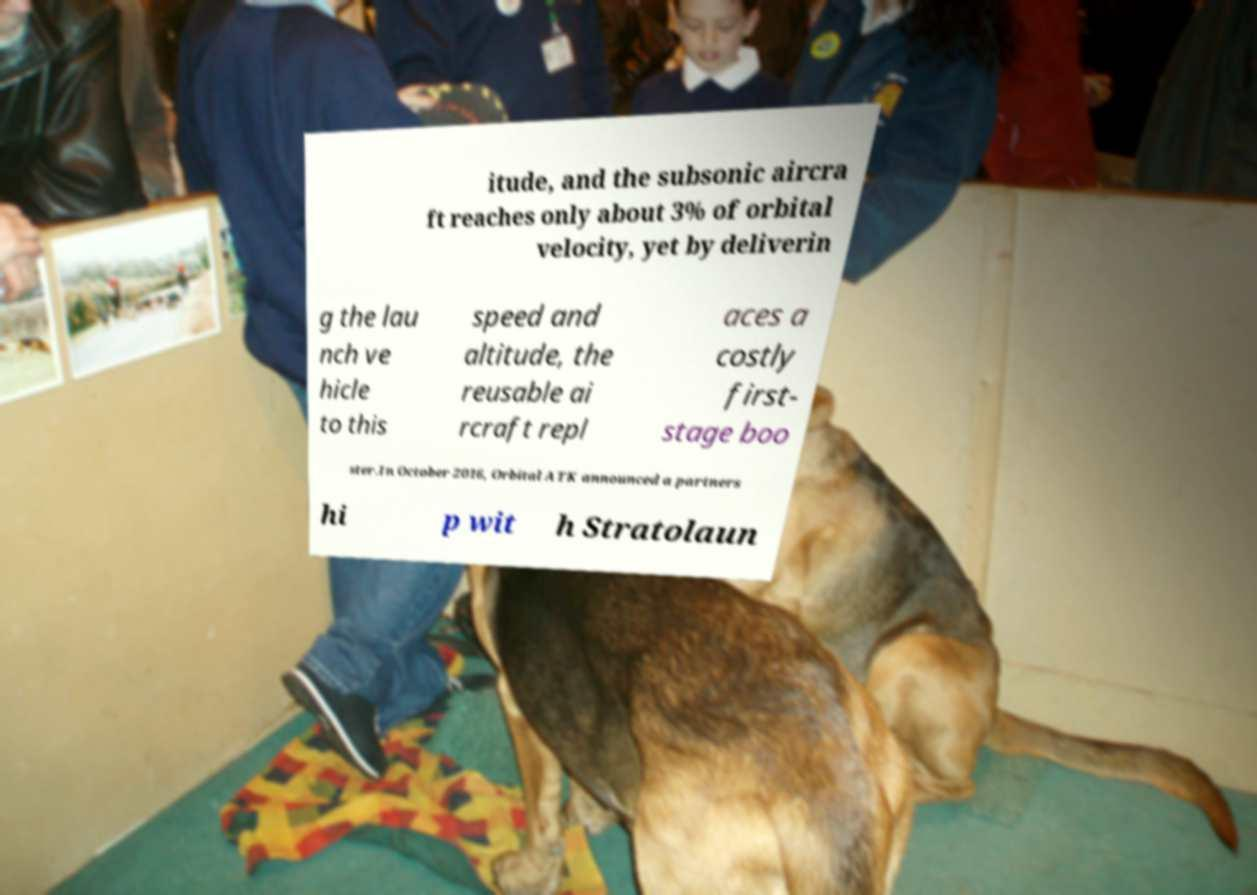I need the written content from this picture converted into text. Can you do that? itude, and the subsonic aircra ft reaches only about 3% of orbital velocity, yet by deliverin g the lau nch ve hicle to this speed and altitude, the reusable ai rcraft repl aces a costly first- stage boo ster.In October 2016, Orbital ATK announced a partners hi p wit h Stratolaun 